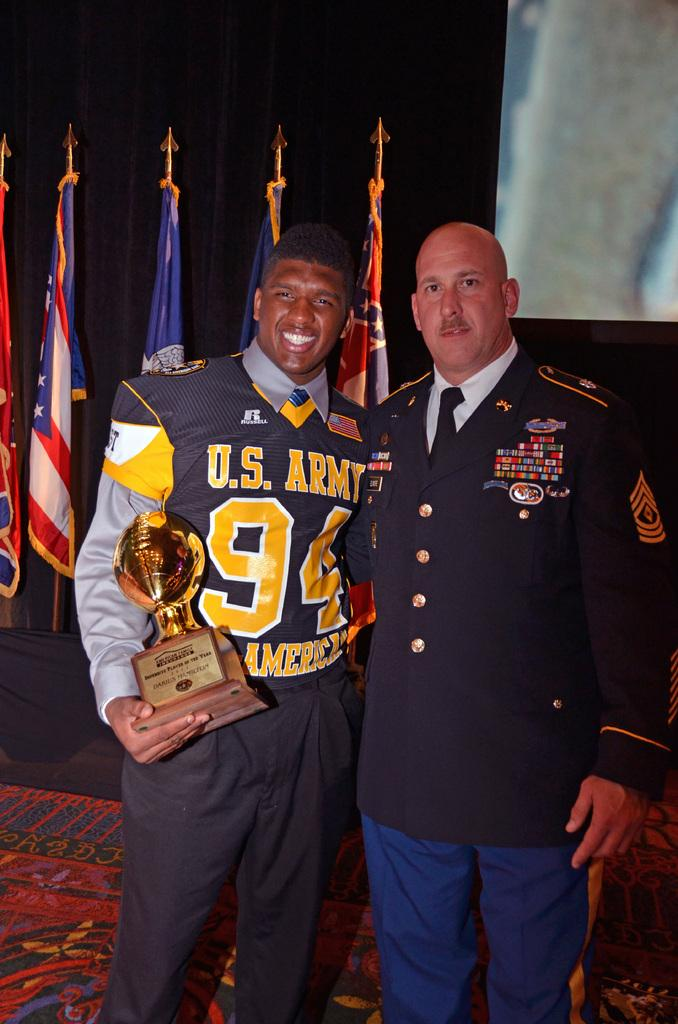<image>
Give a short and clear explanation of the subsequent image. darius hamilton holds his player of the year trophy next to a military officer 